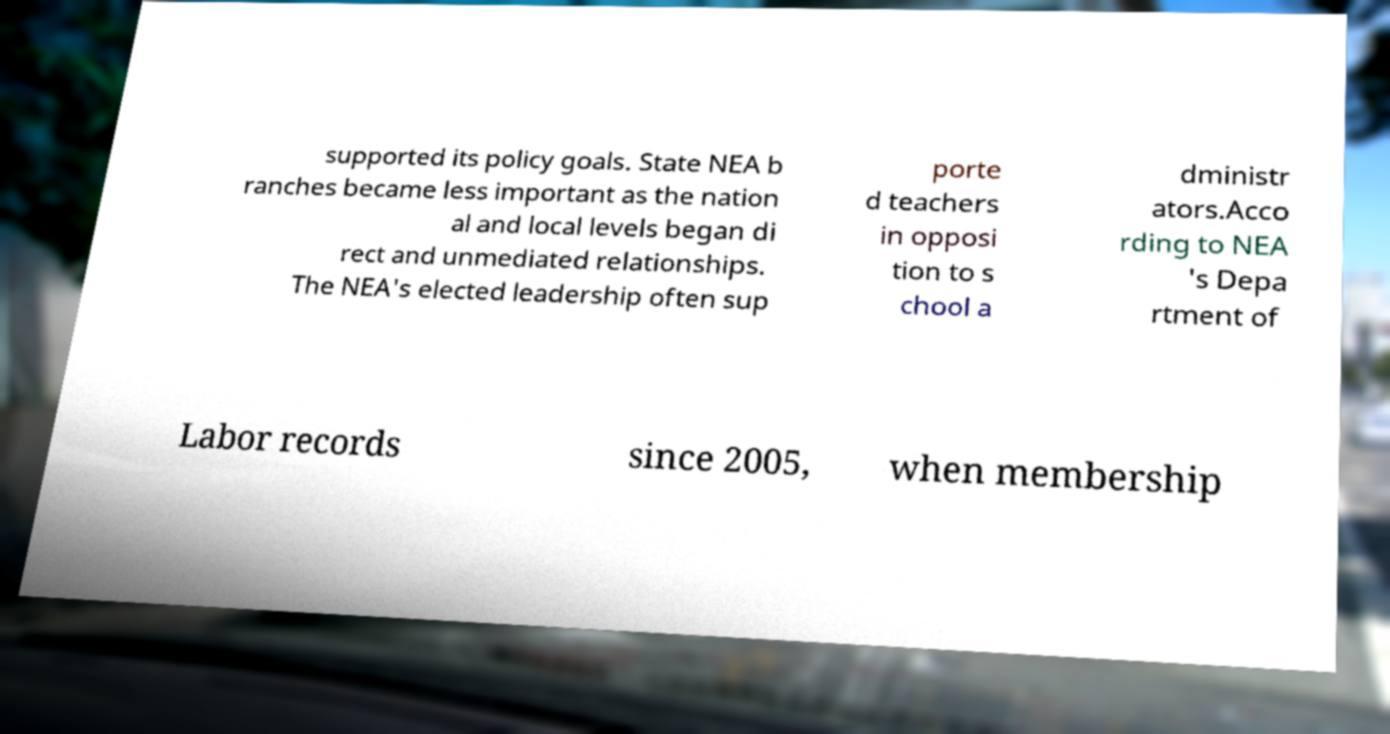I need the written content from this picture converted into text. Can you do that? supported its policy goals. State NEA b ranches became less important as the nation al and local levels began di rect and unmediated relationships. The NEA's elected leadership often sup porte d teachers in opposi tion to s chool a dministr ators.Acco rding to NEA 's Depa rtment of Labor records since 2005, when membership 